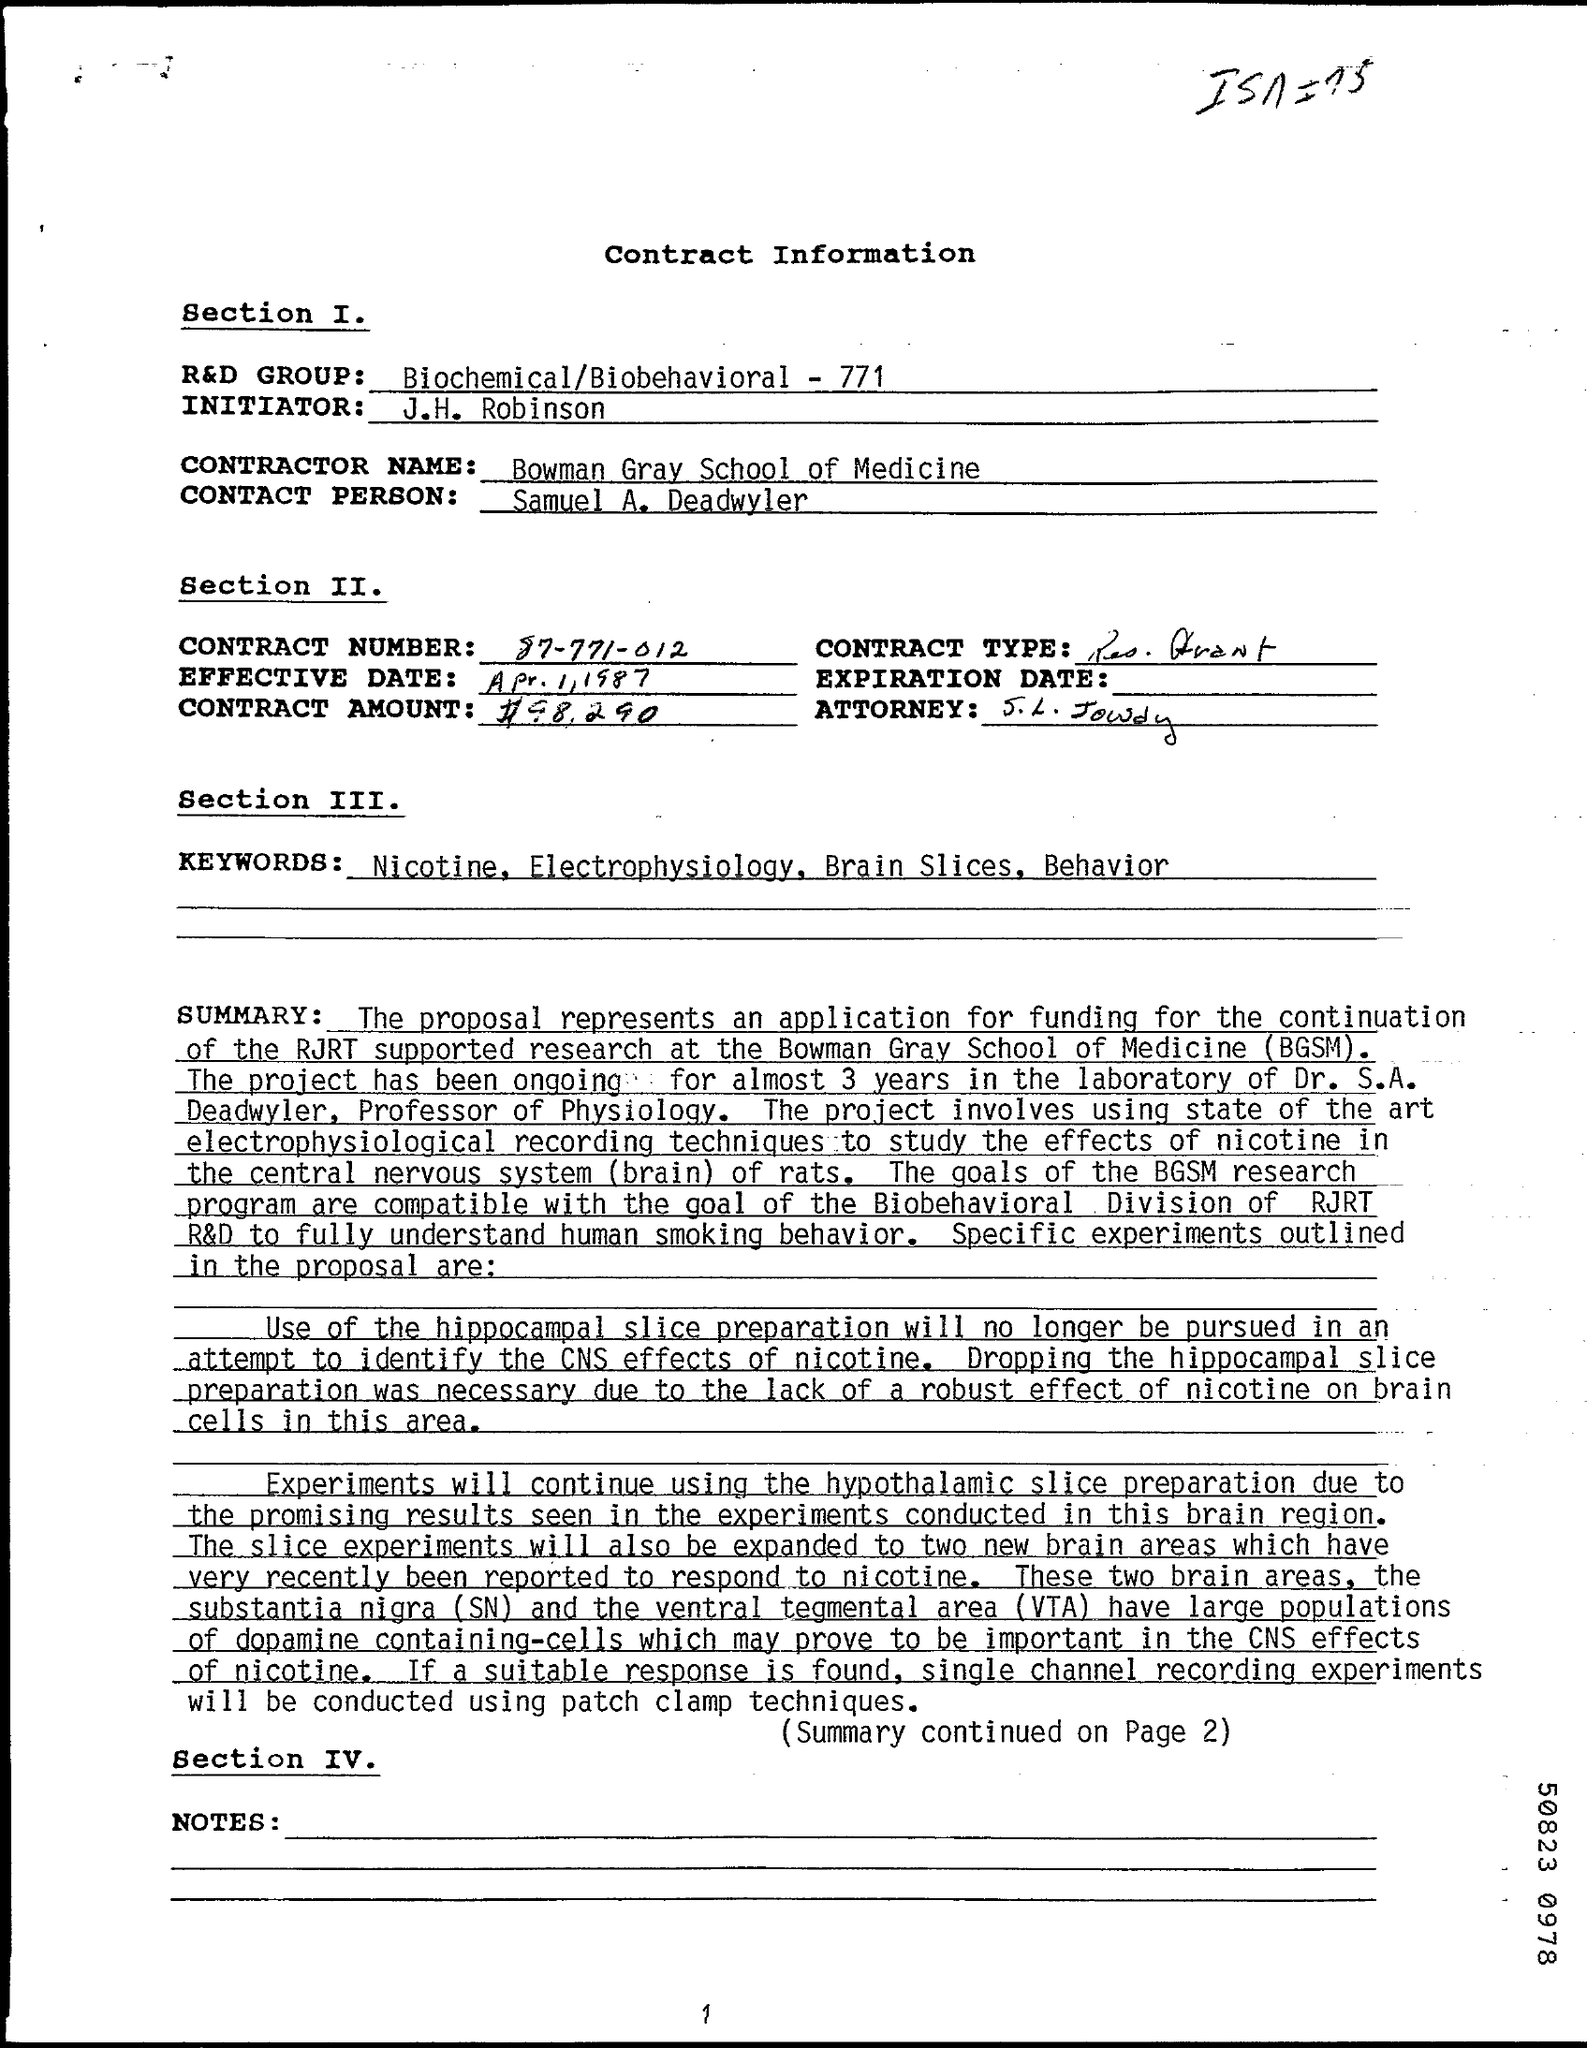Who is the Initiator ?
Ensure brevity in your answer.  J.H. Robinson. Who is the Contact Person ?
Ensure brevity in your answer.  Samuel A. Deadwyler. What is the Contractor Name ?
Ensure brevity in your answer.  Bowman Gray School of Medicine. What is written in the R&D GROUP Field ?
Your answer should be compact. Biochemical/Biobehavioral - 771. What is the Contract Number ?
Make the answer very short. 87-771-012. 